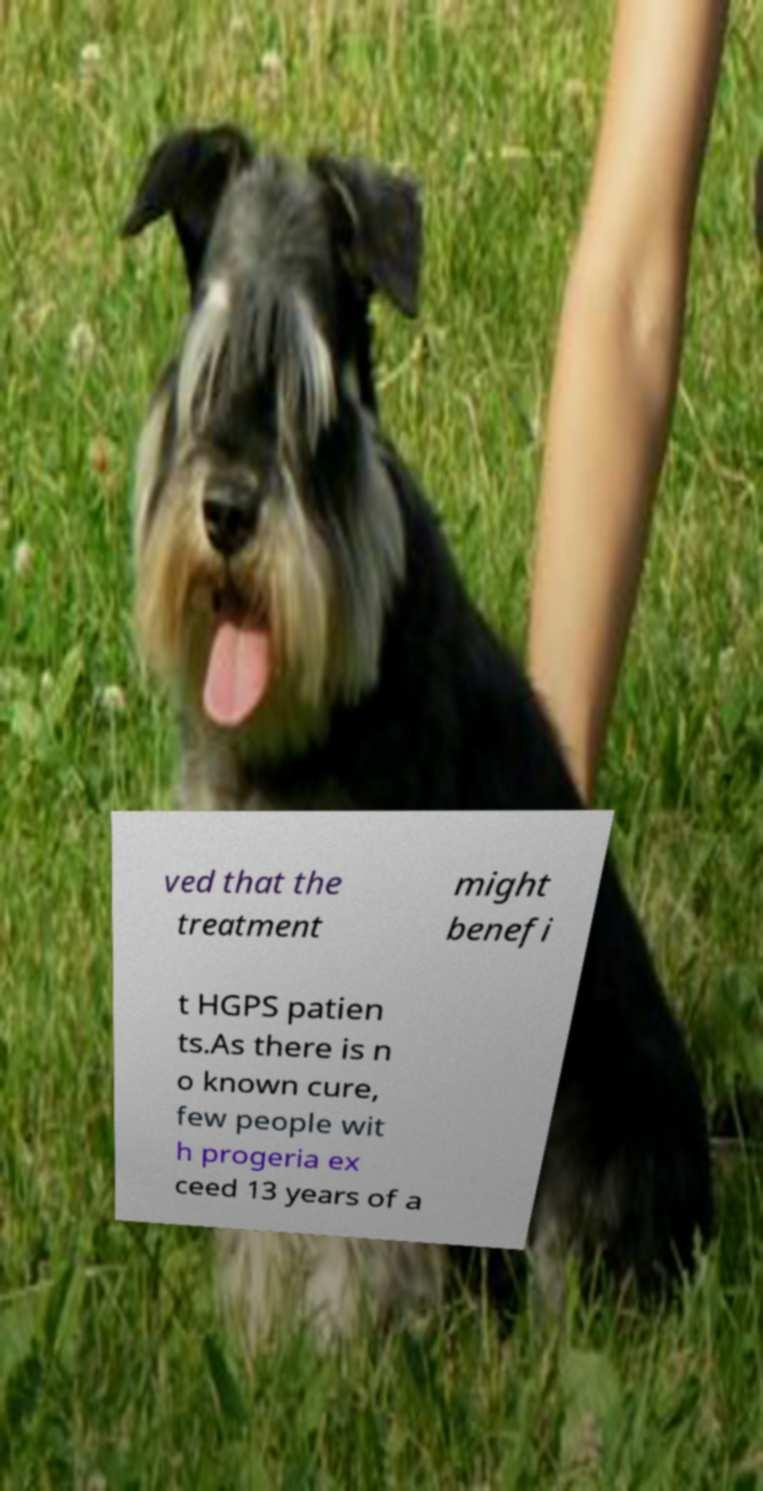Please read and relay the text visible in this image. What does it say? ved that the treatment might benefi t HGPS patien ts.As there is n o known cure, few people wit h progeria ex ceed 13 years of a 